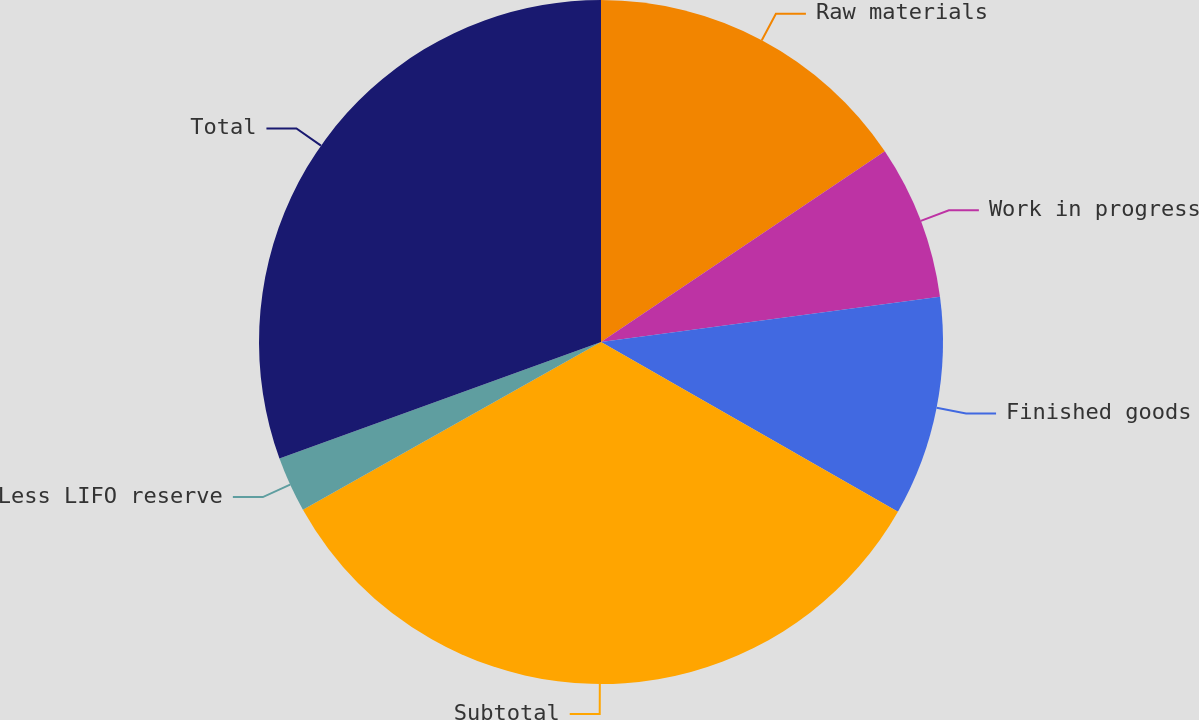Convert chart to OTSL. <chart><loc_0><loc_0><loc_500><loc_500><pie_chart><fcel>Raw materials<fcel>Work in progress<fcel>Finished goods<fcel>Subtotal<fcel>Less LIFO reserve<fcel>Total<nl><fcel>15.58%<fcel>7.31%<fcel>10.37%<fcel>33.58%<fcel>2.62%<fcel>30.53%<nl></chart> 